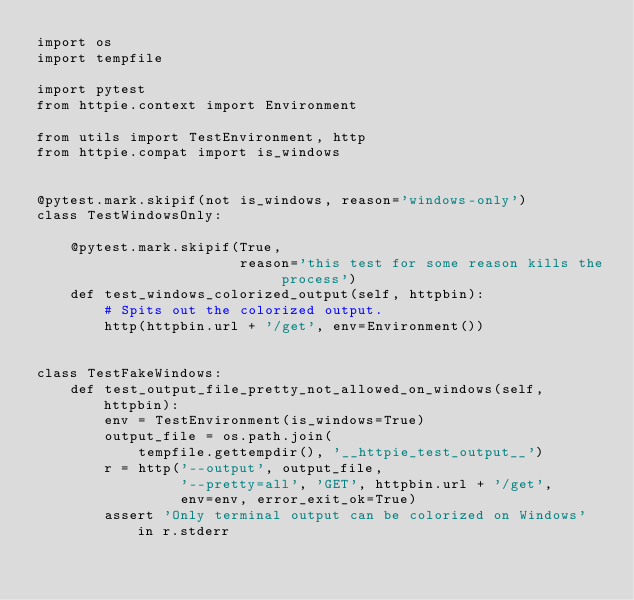<code> <loc_0><loc_0><loc_500><loc_500><_Python_>import os
import tempfile

import pytest
from httpie.context import Environment

from utils import TestEnvironment, http
from httpie.compat import is_windows


@pytest.mark.skipif(not is_windows, reason='windows-only')
class TestWindowsOnly:

    @pytest.mark.skipif(True,
                        reason='this test for some reason kills the process')
    def test_windows_colorized_output(self, httpbin):
        # Spits out the colorized output.
        http(httpbin.url + '/get', env=Environment())


class TestFakeWindows:
    def test_output_file_pretty_not_allowed_on_windows(self, httpbin):
        env = TestEnvironment(is_windows=True)
        output_file = os.path.join(
            tempfile.gettempdir(), '__httpie_test_output__')
        r = http('--output', output_file,
                 '--pretty=all', 'GET', httpbin.url + '/get',
                 env=env, error_exit_ok=True)
        assert 'Only terminal output can be colorized on Windows' in r.stderr
</code> 